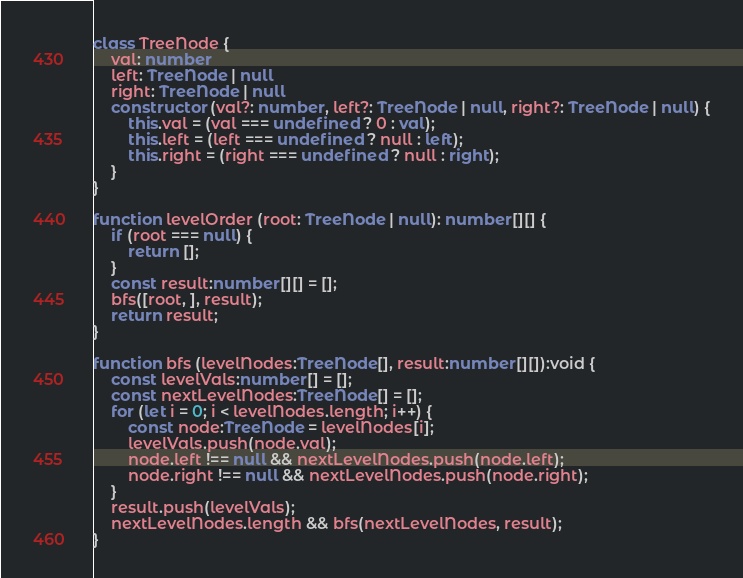<code> <loc_0><loc_0><loc_500><loc_500><_TypeScript_>class TreeNode {
    val: number
    left: TreeNode | null
    right: TreeNode | null
    constructor (val?: number, left?: TreeNode | null, right?: TreeNode | null) {
        this.val = (val === undefined ? 0 : val);
        this.left = (left === undefined ? null : left);
        this.right = (right === undefined ? null : right);
    }
}

function levelOrder (root: TreeNode | null): number[][] {
    if (root === null) {
        return [];
    }
    const result:number[][] = [];
    bfs([root, ], result);
    return result;
}

function bfs (levelNodes:TreeNode[], result:number[][]):void {
    const levelVals:number[] = [];
    const nextLevelNodes:TreeNode[] = [];
    for (let i = 0; i < levelNodes.length; i++) {
        const node:TreeNode = levelNodes[i];
        levelVals.push(node.val);
        node.left !== null && nextLevelNodes.push(node.left);
        node.right !== null && nextLevelNodes.push(node.right);
    }
    result.push(levelVals);
    nextLevelNodes.length && bfs(nextLevelNodes, result);
}
</code> 